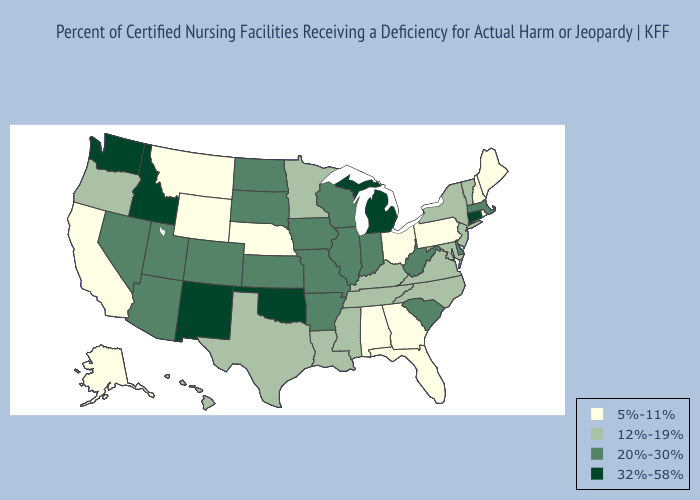What is the value of Iowa?
Be succinct. 20%-30%. Does Utah have a higher value than Michigan?
Give a very brief answer. No. Does Florida have a higher value than North Carolina?
Write a very short answer. No. Name the states that have a value in the range 5%-11%?
Write a very short answer. Alabama, Alaska, California, Florida, Georgia, Maine, Montana, Nebraska, New Hampshire, Ohio, Pennsylvania, Rhode Island, Wyoming. Among the states that border Rhode Island , which have the lowest value?
Be succinct. Massachusetts. What is the highest value in states that border Minnesota?
Write a very short answer. 20%-30%. What is the value of Texas?
Quick response, please. 12%-19%. Among the states that border New Hampshire , which have the highest value?
Give a very brief answer. Massachusetts. What is the value of New Jersey?
Concise answer only. 12%-19%. What is the highest value in the MidWest ?
Give a very brief answer. 32%-58%. What is the value of Arizona?
Be succinct. 20%-30%. Which states have the lowest value in the West?
Write a very short answer. Alaska, California, Montana, Wyoming. Is the legend a continuous bar?
Be succinct. No. What is the value of Massachusetts?
Quick response, please. 20%-30%. Does New Mexico have the highest value in the USA?
Give a very brief answer. Yes. 